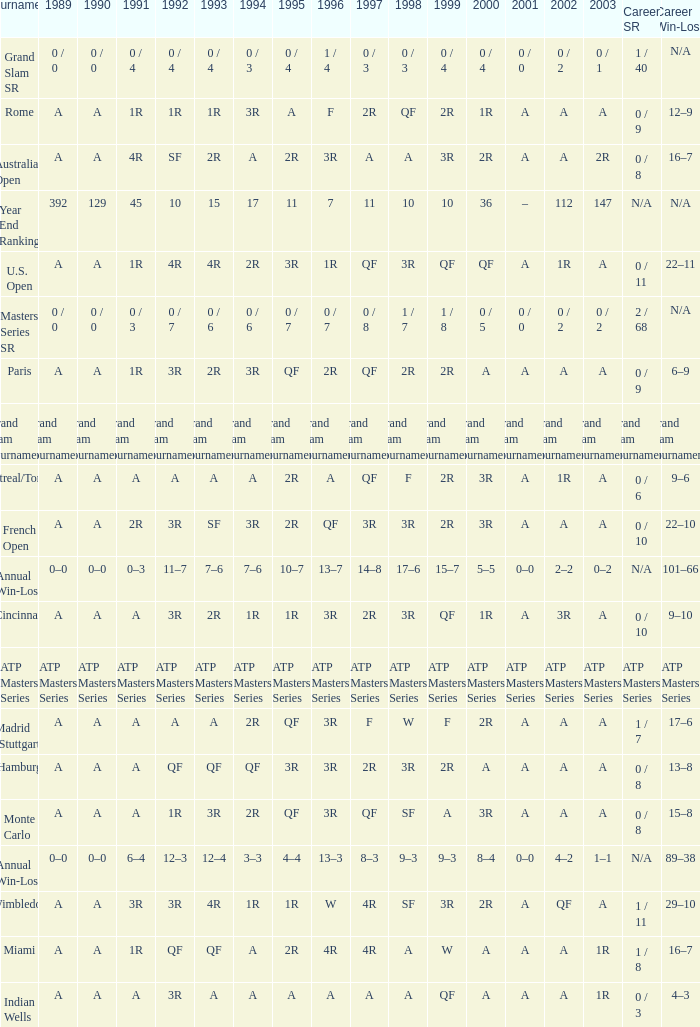What is the value in 1997 when the value in 1989 is A, 1995 is QF, 1996 is 3R and the career SR is 0 / 8? QF. 